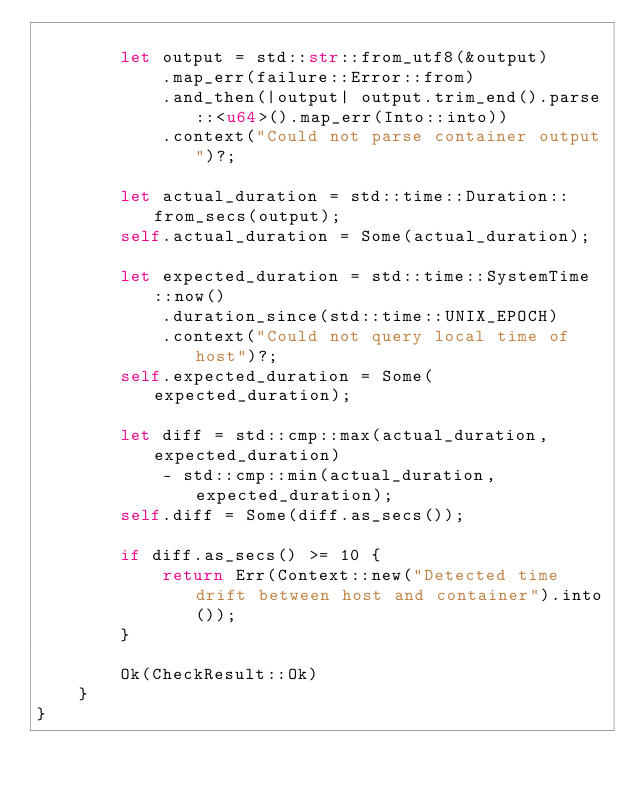<code> <loc_0><loc_0><loc_500><loc_500><_Rust_>
        let output = std::str::from_utf8(&output)
            .map_err(failure::Error::from)
            .and_then(|output| output.trim_end().parse::<u64>().map_err(Into::into))
            .context("Could not parse container output")?;

        let actual_duration = std::time::Duration::from_secs(output);
        self.actual_duration = Some(actual_duration);

        let expected_duration = std::time::SystemTime::now()
            .duration_since(std::time::UNIX_EPOCH)
            .context("Could not query local time of host")?;
        self.expected_duration = Some(expected_duration);

        let diff = std::cmp::max(actual_duration, expected_duration)
            - std::cmp::min(actual_duration, expected_duration);
        self.diff = Some(diff.as_secs());

        if diff.as_secs() >= 10 {
            return Err(Context::new("Detected time drift between host and container").into());
        }

        Ok(CheckResult::Ok)
    }
}
</code> 